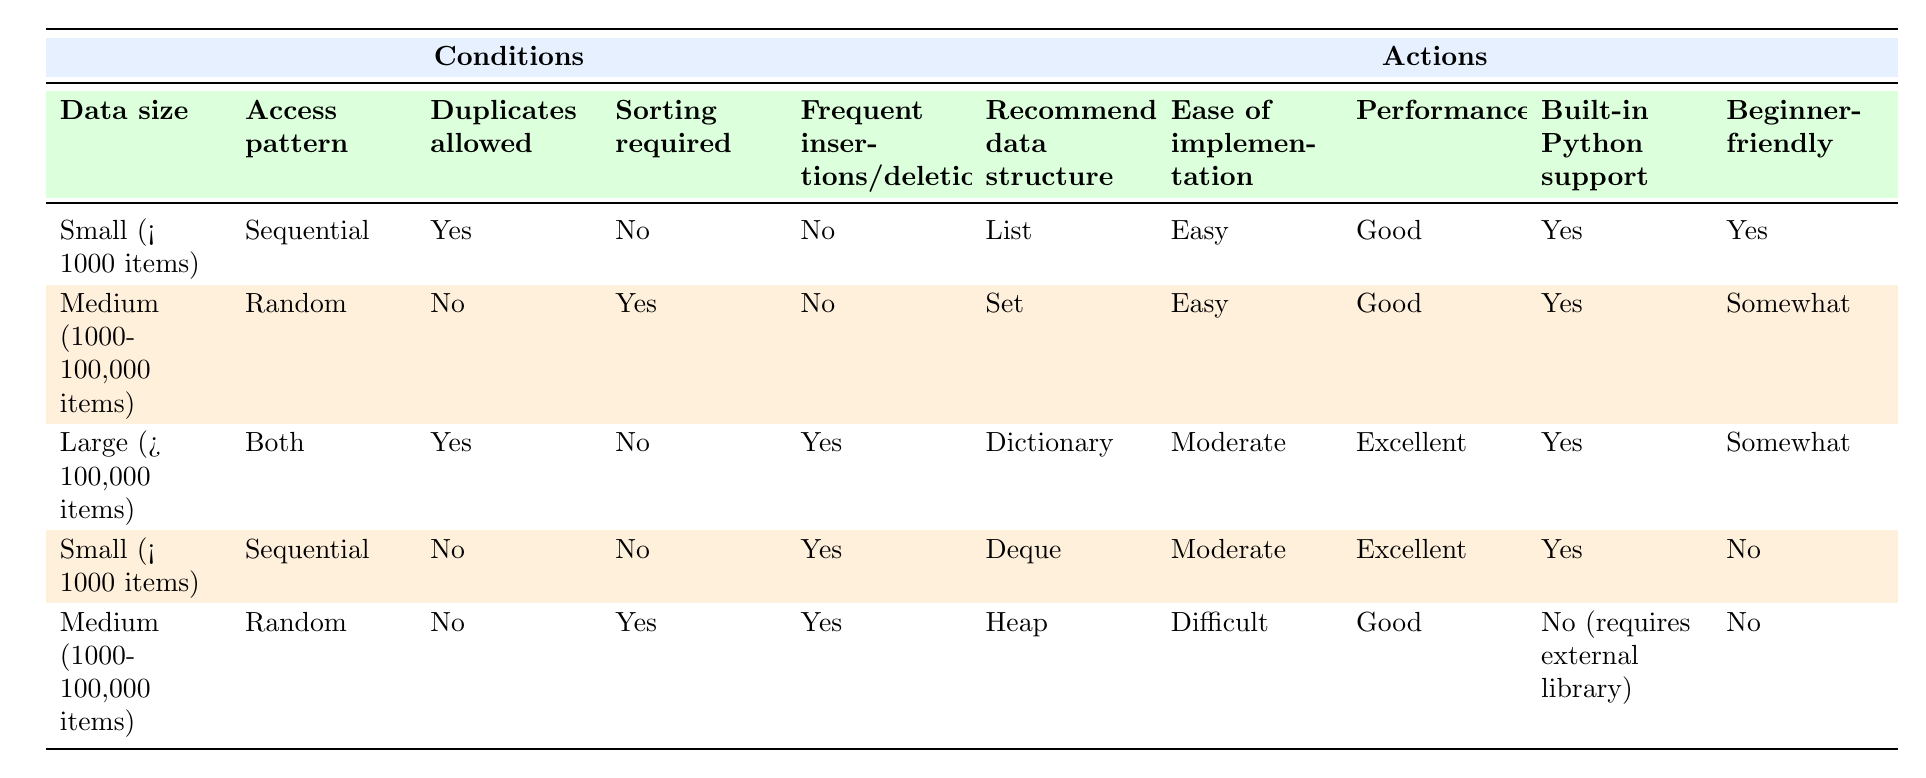What recommended data structure is suitable for small data size with sequential access, allowing duplicates and not requiring sorting? From the table, we look at the row corresponding to "Small (< 1000 items)", "Sequential", "Yes", "No", "No". The recommended data structure for this condition is "List".
Answer: List What is the ease of implementation for a recommended data structure for medium data size with a random access pattern, allowing no duplicates, requiring sorting, and having no frequent insertions/deletions? We check the table for "Medium (1000-100,000 items)", "Random", "No", "Yes", "No". This matches with "Set", which has "Easy" for ease of implementation.
Answer: Easy True or False: A Deque is beginner-friendly when used for small data size, sequential access without duplicates but allowing frequent insertions and deletions. The table shows for "Small (< 1000 items)", "Sequential", "No", "No", "Yes", the recommended data structure is "Deque" and it is marked as "No" for beginner-friendly. Thus, it is false.
Answer: False Which data structure is recommended for managing large data sizes with both access patterns, allowing duplicates, not requiring sorting, and having frequent insertions and deletions? By checking the table, for "Large (> 100,000 items)", "Both", "Yes", "No", "Yes", the recommended structure is "Dictionary".
Answer: Dictionary What is the performance rating for a recommended data structure for medium data size, random access pattern, not allowing duplicates, requiring sorting, and having frequent insertions and deletions? We look for "Medium (1000-100,000 items)", "Random", "No", "Yes", "Yes". This row corresponds to "Heap", which has a "Good" performance rating.
Answer: Good If we categorize beginner-friendly data structures, how many are there in total for small data sizes? We count the rows for "Small (< 1000 items)": "List" (Yes for beginner-friendly) and "Deque" (No). So there is a total of 1 beginner-friendly data structure ("List").
Answer: 1 What variance exists between the performance evaluations of "Set" and "Heap"? For "Set", the performance rating is "Good". For "Heap", the performance rating is also "Good". Thus, there is no variance as they are the same.
Answer: No variance What data structures are easy to implement for any of the conditions given? Checking the table, we find that the structures marked as "Easy" are "List" and "Set". There are 2 structures that are easy to implement.
Answer: 2 What are the built-in Python support statuses for both Deque and Heap? From the table, "Deque" is marked as "Yes" for built-in Python support, while "Heap" is marked as "No (requires external library)".
Answer: Yes for Deque, No for Heap 